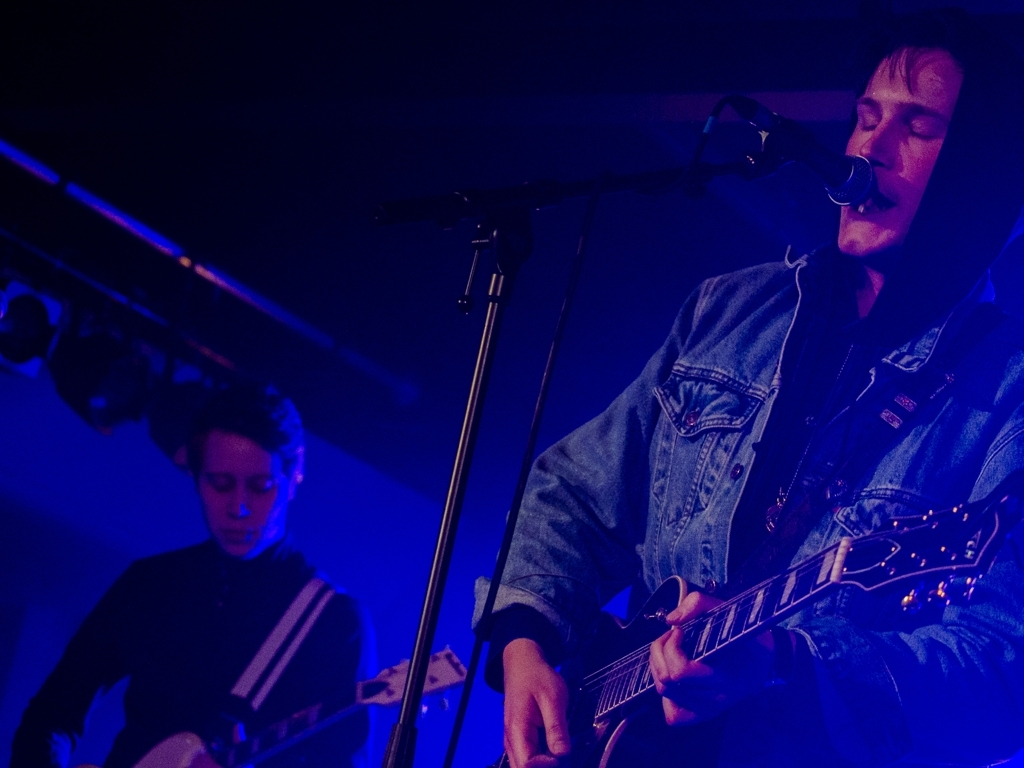What do you think is happening in this image? It looks like a live music performance in a small venue, where the musicians are deeply engrossed in their performance. The main subject is playing the guitar and singing into a microphone, while another person appears to be accompanying on bass. 